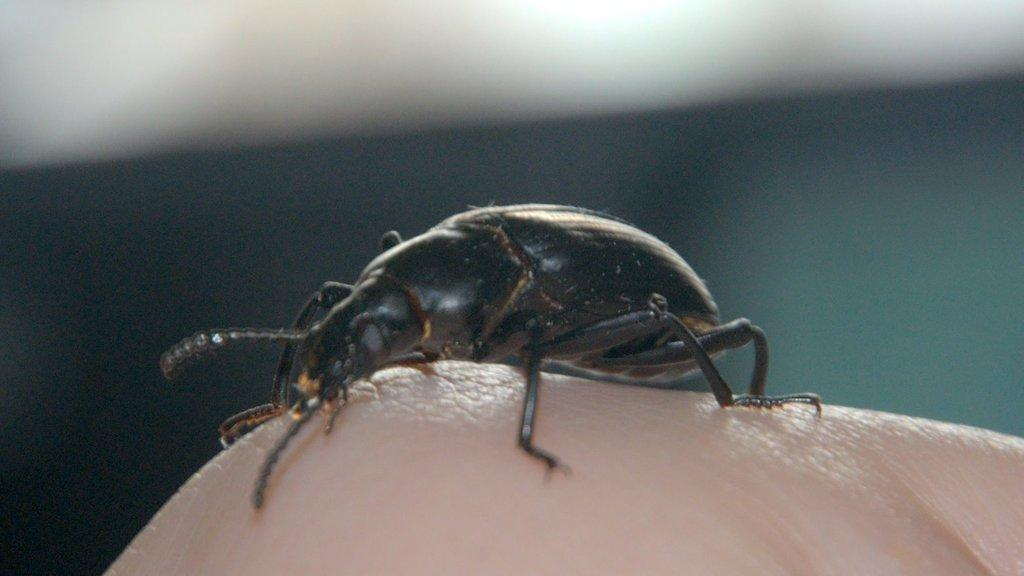What is present on the finger of the person in the image? There is a bug on the finger of the person in the image. Can you describe the bug in the image? Unfortunately, the image does not provide enough detail to describe the bug. What type of key is the bug holding in the image? There is no key present in the image; it only features a bug on the finger of a person. 